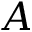<formula> <loc_0><loc_0><loc_500><loc_500>A</formula> 